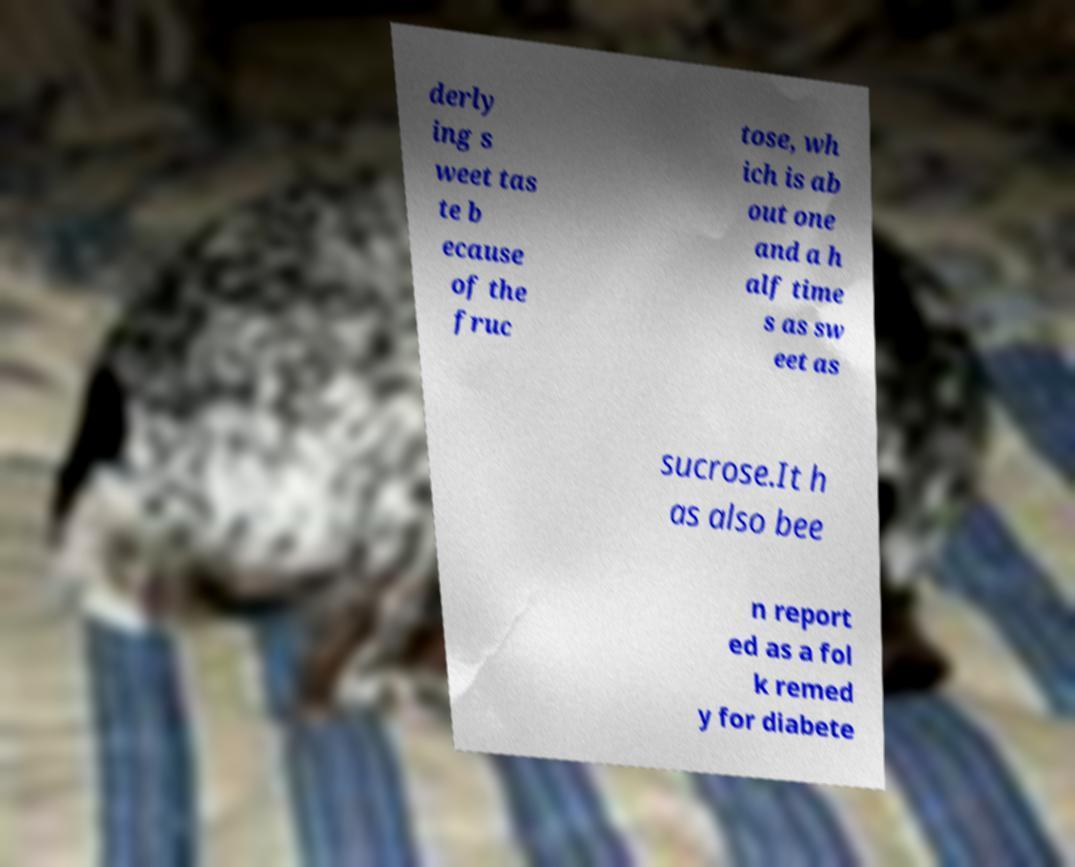Could you assist in decoding the text presented in this image and type it out clearly? derly ing s weet tas te b ecause of the fruc tose, wh ich is ab out one and a h alf time s as sw eet as sucrose.It h as also bee n report ed as a fol k remed y for diabete 